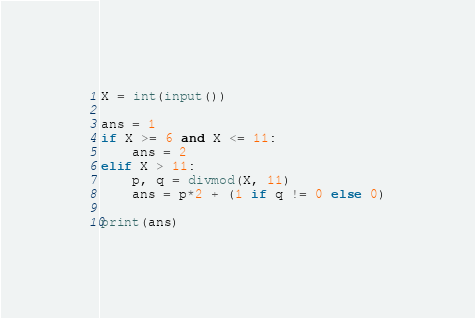<code> <loc_0><loc_0><loc_500><loc_500><_Python_>X = int(input())

ans = 1
if X >= 6 and X <= 11:
    ans = 2
elif X > 11:
    p, q = divmod(X, 11)
    ans = p*2 + (1 if q != 0 else 0)

print(ans)
</code> 